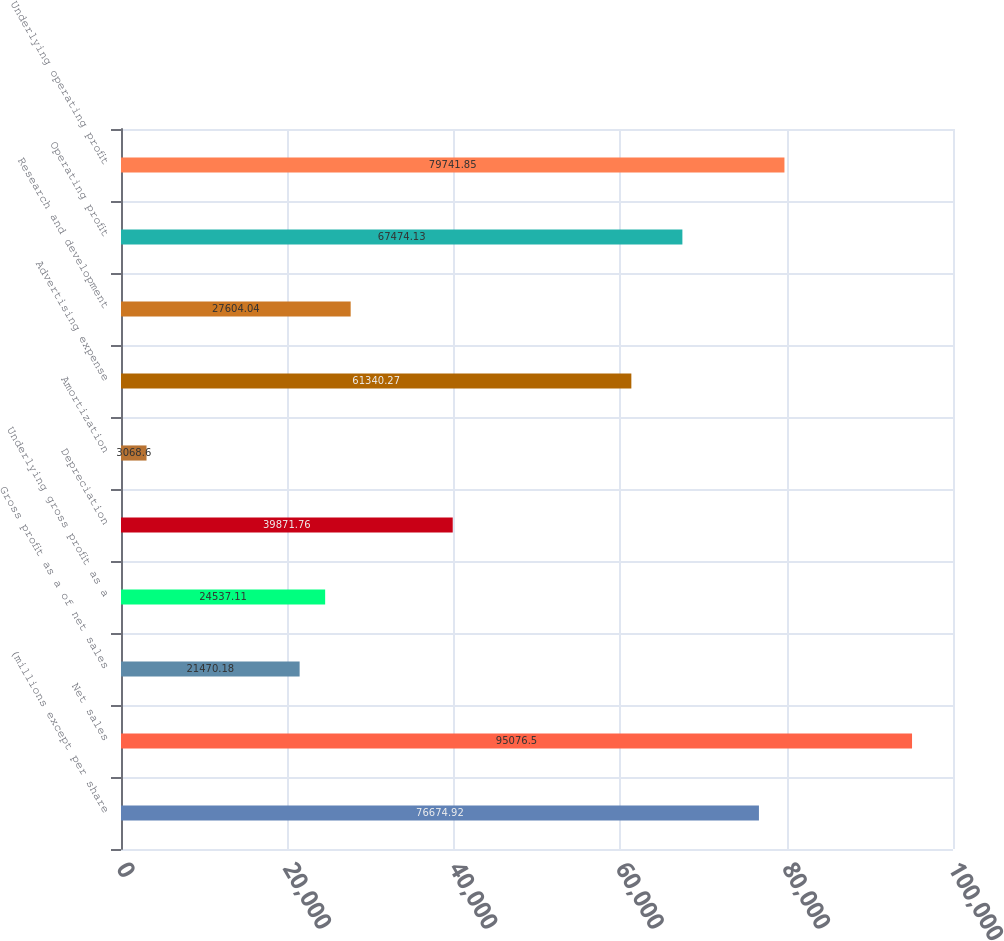<chart> <loc_0><loc_0><loc_500><loc_500><bar_chart><fcel>(millions except per share<fcel>Net sales<fcel>Gross profit as a of net sales<fcel>Underlying gross profit as a<fcel>Depreciation<fcel>Amortization<fcel>Advertising expense<fcel>Research and development<fcel>Operating profit<fcel>Underlying operating profit<nl><fcel>76674.9<fcel>95076.5<fcel>21470.2<fcel>24537.1<fcel>39871.8<fcel>3068.6<fcel>61340.3<fcel>27604<fcel>67474.1<fcel>79741.9<nl></chart> 